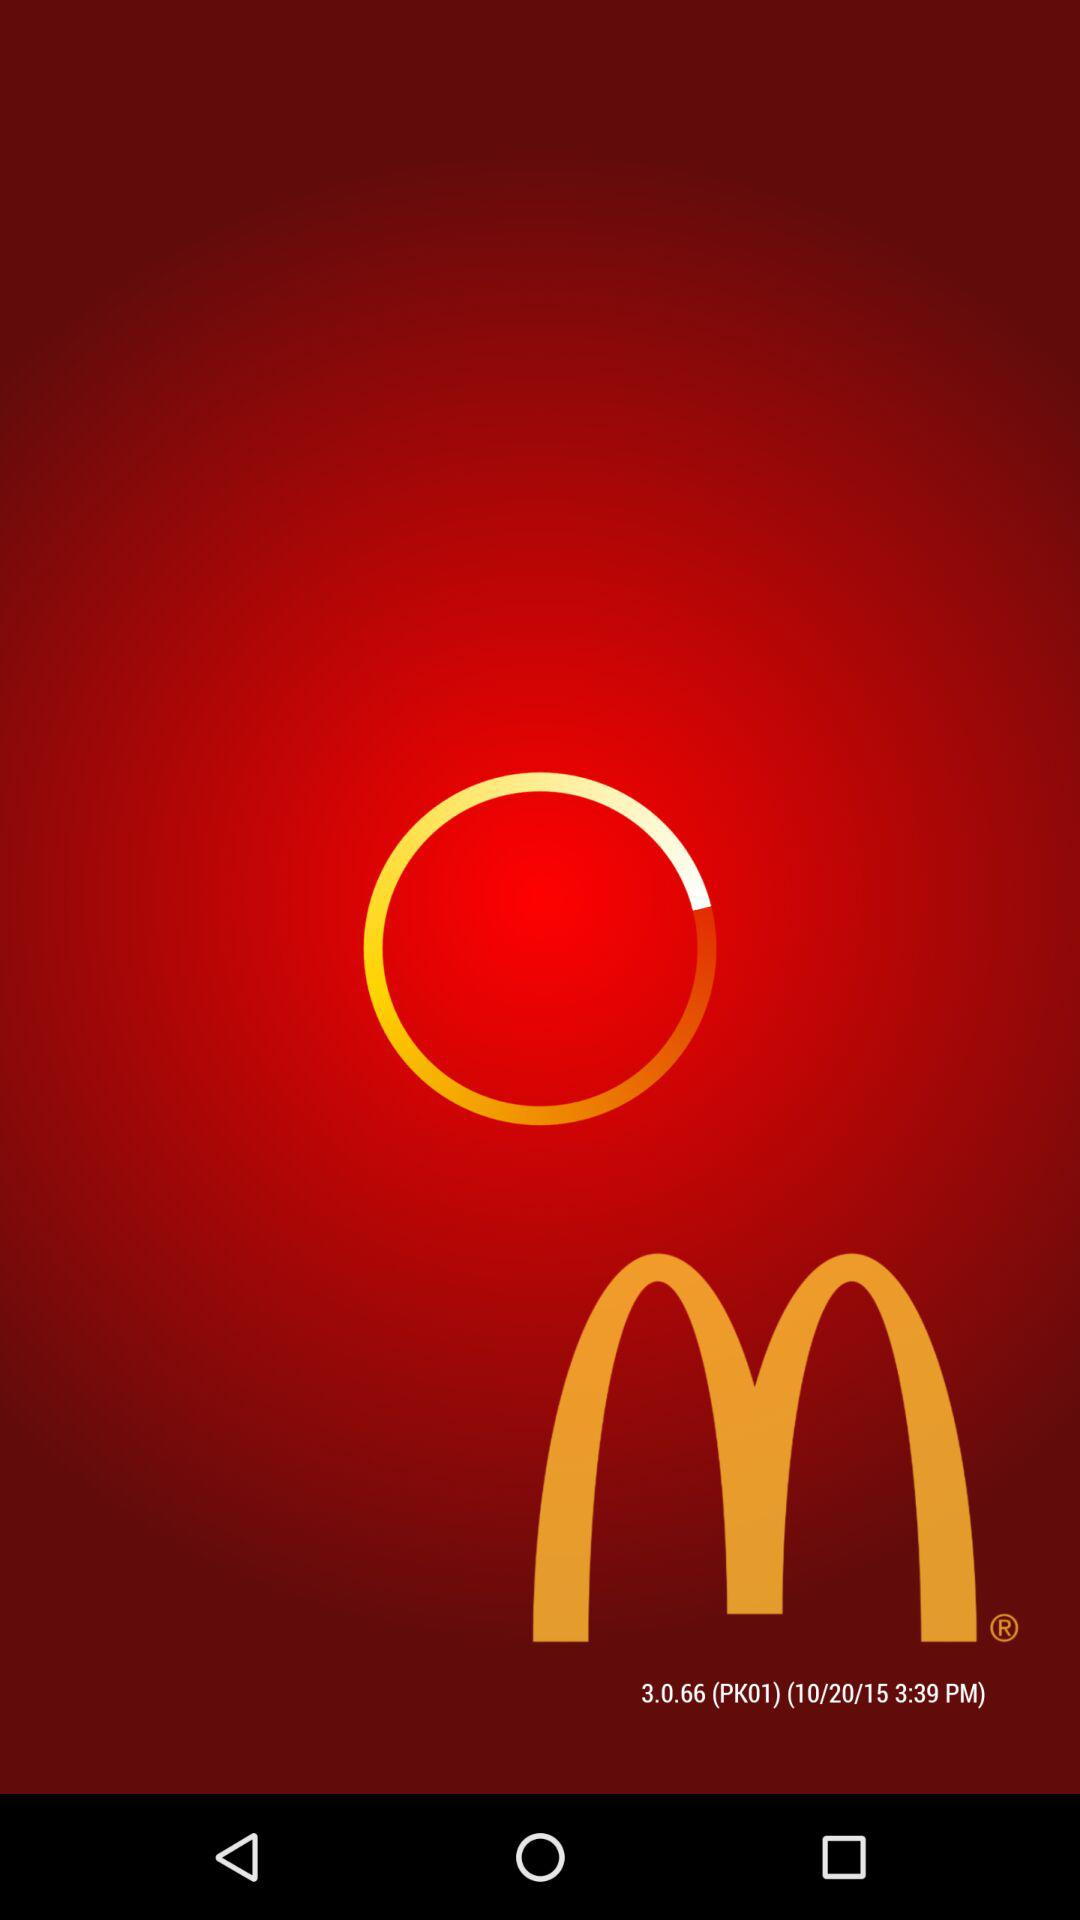What is the date? The date is 10/20/15. 